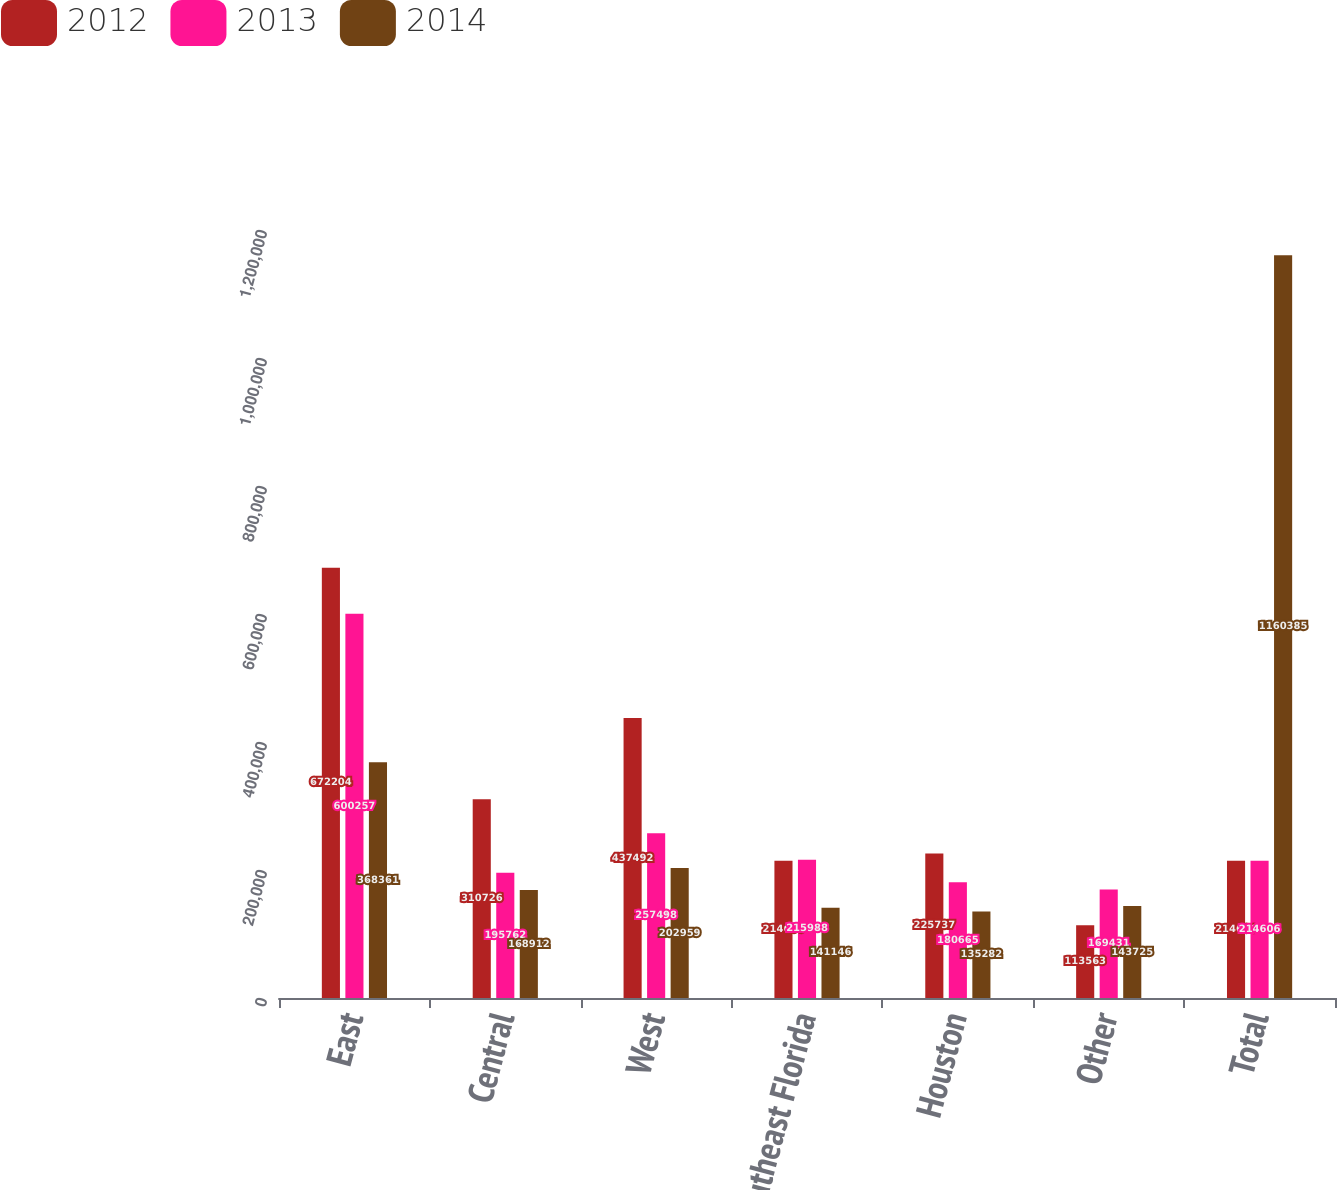Convert chart. <chart><loc_0><loc_0><loc_500><loc_500><stacked_bar_chart><ecel><fcel>East<fcel>Central<fcel>West<fcel>Southeast Florida<fcel>Houston<fcel>Other<fcel>Total<nl><fcel>2012<fcel>672204<fcel>310726<fcel>437492<fcel>214606<fcel>225737<fcel>113563<fcel>214606<nl><fcel>2013<fcel>600257<fcel>195762<fcel>257498<fcel>215988<fcel>180665<fcel>169431<fcel>214606<nl><fcel>2014<fcel>368361<fcel>168912<fcel>202959<fcel>141146<fcel>135282<fcel>143725<fcel>1.16038e+06<nl></chart> 